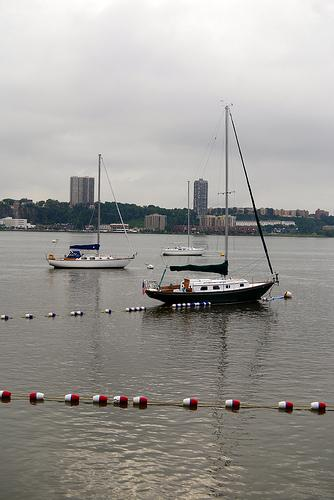Identify the color of the sail on the black and white sailboat. The sail is black. List the colors of the different buoys in the image. Red and white, blue and white. How would you describe the state of the water in the image? The water is calm. What is the sentiment associated with the image? Peaceful and serene. Estimate the quality of the image based on the objects within it. High-quality due to the attention to detail in the boats, buoys, and the environment. Analyze the interaction between the different boats in the image. The boats are anchored in the water, not interacting with each other and instead, maintaining a safe distance apart. Which object has an American flag on it? The stern of the sailboat. Count the number of white clouds in the blue sky. There are no white clouds in the sky; the sky is overcast. Briefly describe the setting of the image. A bay with several boats and calm water, with a blue sky and white clouds overhead. Which object can be associated with the skyline of the city? The buildings in the background. 